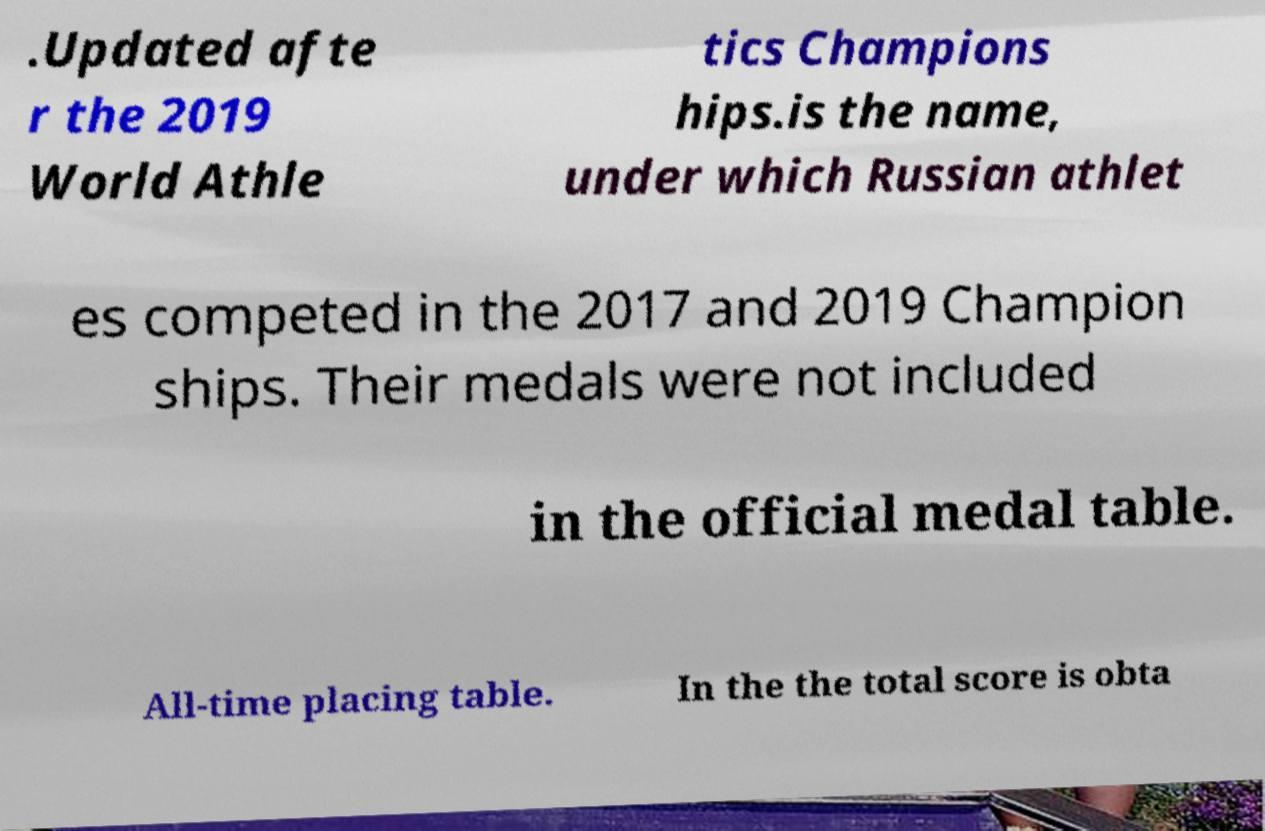Please identify and transcribe the text found in this image. .Updated afte r the 2019 World Athle tics Champions hips.is the name, under which Russian athlet es competed in the 2017 and 2019 Champion ships. Their medals were not included in the official medal table. All-time placing table. In the the total score is obta 